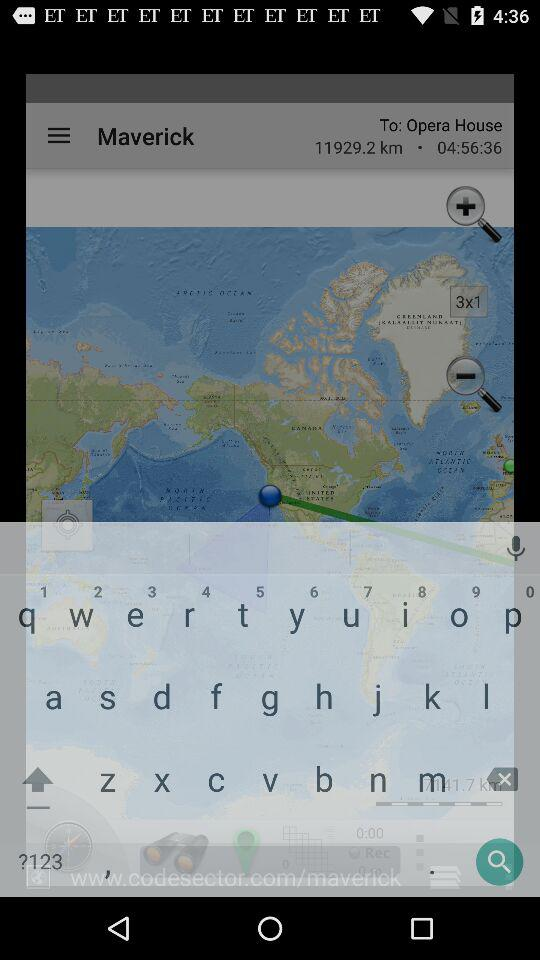How long is the estimated time of arrival?
Answer the question using a single word or phrase. 04:56:36 